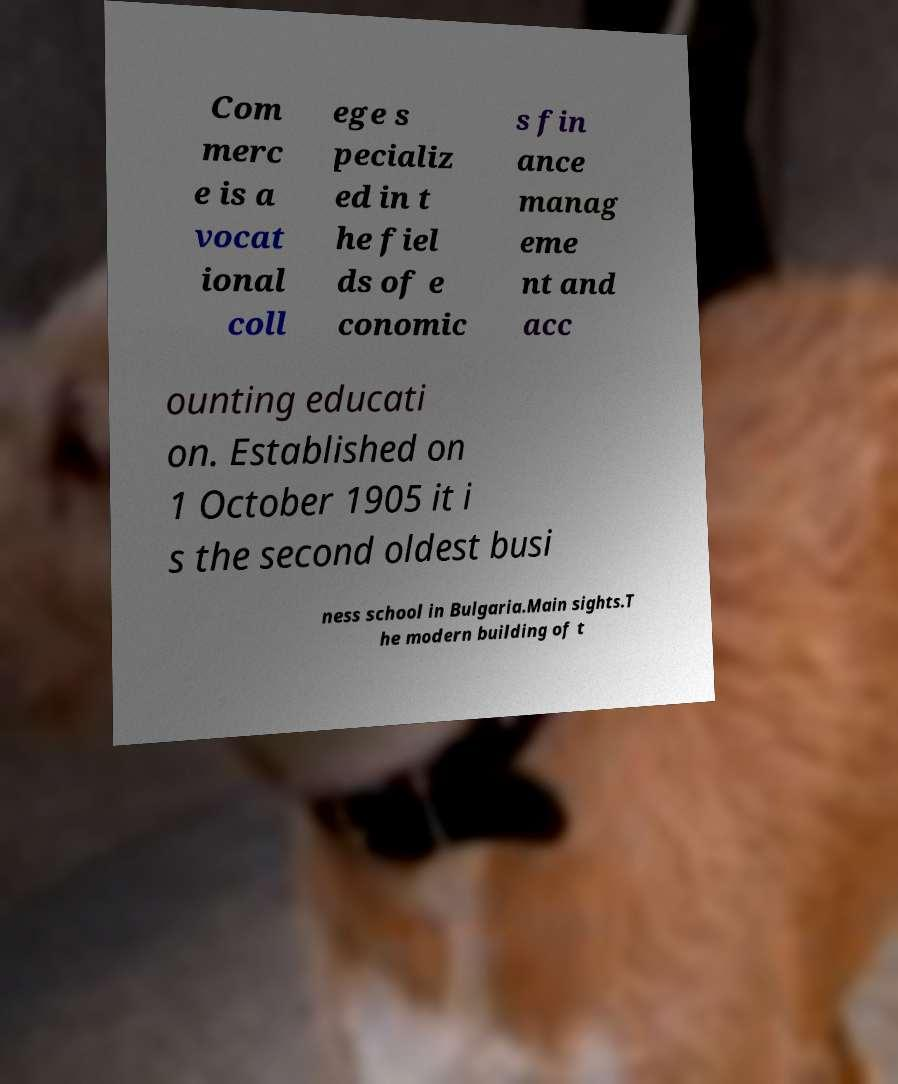Could you extract and type out the text from this image? Com merc e is a vocat ional coll ege s pecializ ed in t he fiel ds of e conomic s fin ance manag eme nt and acc ounting educati on. Established on 1 October 1905 it i s the second oldest busi ness school in Bulgaria.Main sights.T he modern building of t 